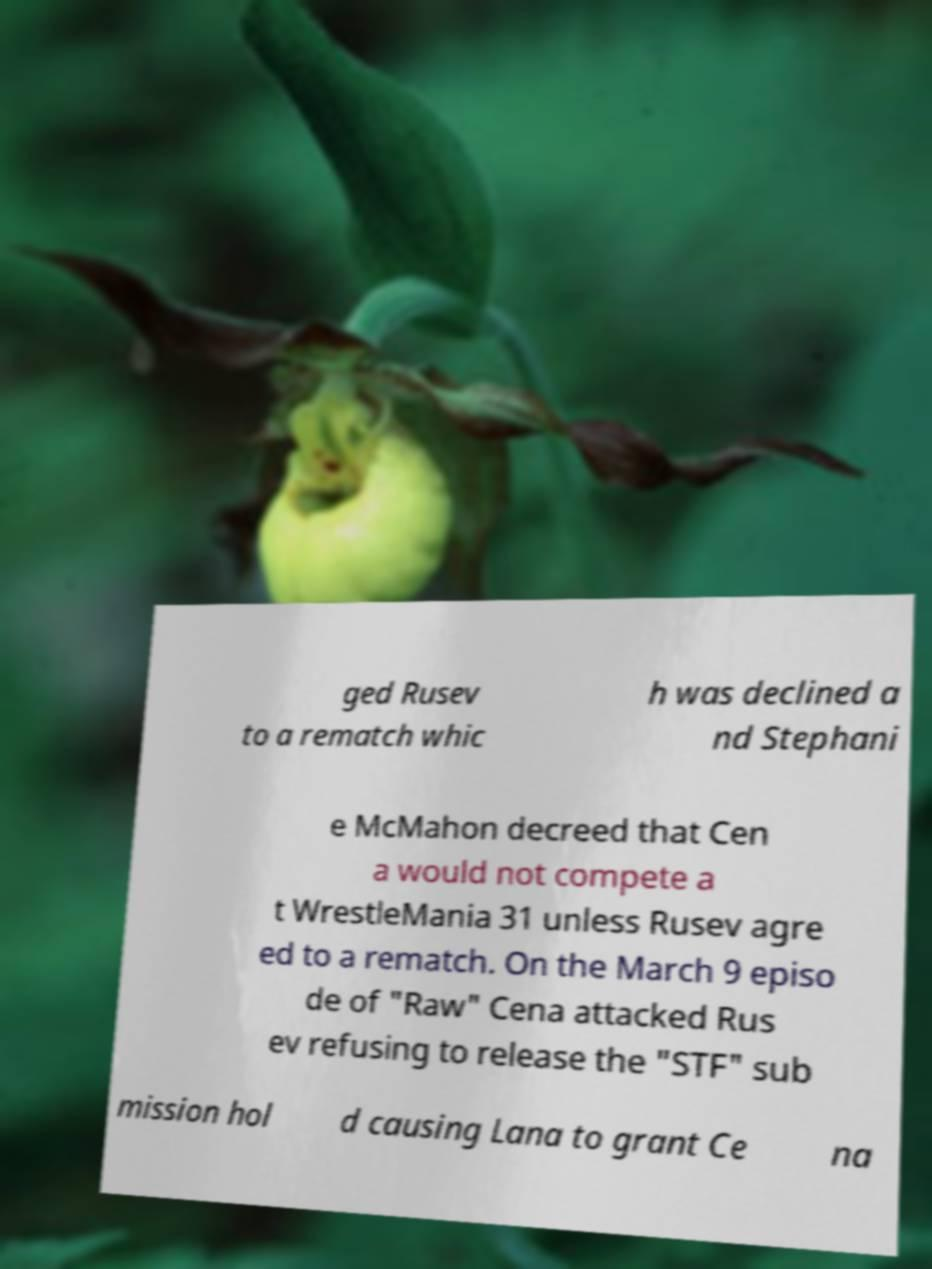Please identify and transcribe the text found in this image. ged Rusev to a rematch whic h was declined a nd Stephani e McMahon decreed that Cen a would not compete a t WrestleMania 31 unless Rusev agre ed to a rematch. On the March 9 episo de of "Raw" Cena attacked Rus ev refusing to release the "STF" sub mission hol d causing Lana to grant Ce na 